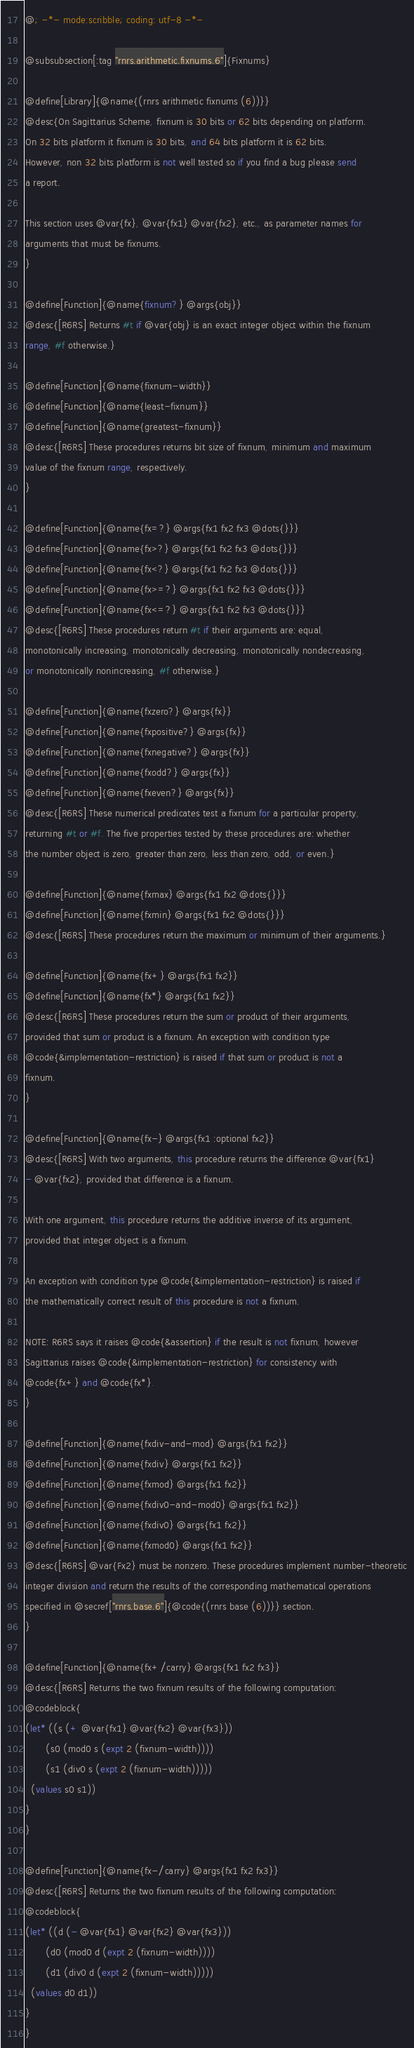Convert code to text. <code><loc_0><loc_0><loc_500><loc_500><_Racket_>@; -*- mode:scribble; coding: utf-8 -*-

@subsubsection[:tag "rnrs.arithmetic.fixnums.6"]{Fixnums}

@define[Library]{@name{(rnrs arithmetic fixnums (6))}}
@desc{On Sagittarius Scheme, fixnum is 30 bits or 62 bits depending on platform.
On 32 bits platform it fixnum is 30 bits, and 64 bits platform it is 62 bits.
However, non 32 bits platform is not well tested so if you find a bug please send
a report.

This section uses @var{fx}, @var{fx1} @var{fx2}, etc., as parameter names for
arguments that must be fixnums.
}

@define[Function]{@name{fixnum?} @args{obj}}
@desc{[R6RS] Returns #t if @var{obj} is an exact integer object within the fixnum
range, #f otherwise.}

@define[Function]{@name{fixnum-width}}
@define[Function]{@name{least-fixnum}}
@define[Function]{@name{greatest-fixnum}}
@desc{[R6RS] These procedures returns bit size of fixnum, minimum and maximum
value of the fixnum range, respectively.
}

@define[Function]{@name{fx=?} @args{fx1 fx2 fx3 @dots{}}}
@define[Function]{@name{fx>?} @args{fx1 fx2 fx3 @dots{}}}
@define[Function]{@name{fx<?} @args{fx1 fx2 fx3 @dots{}}}
@define[Function]{@name{fx>=?} @args{fx1 fx2 fx3 @dots{}}}
@define[Function]{@name{fx<=?} @args{fx1 fx2 fx3 @dots{}}}
@desc{[R6RS] These procedures return #t if their arguments are: equal,
monotonically increasing, monotonically decreasing, monotonically nondecreasing,
or monotonically nonincreasing, #f otherwise.}

@define[Function]{@name{fxzero?} @args{fx}}
@define[Function]{@name{fxpositive?} @args{fx}}
@define[Function]{@name{fxnegative?} @args{fx}}
@define[Function]{@name{fxodd?} @args{fx}}
@define[Function]{@name{fxeven?} @args{fx}}
@desc{[R6RS] These numerical predicates test a fixnum for a particular property,
returning #t or #f. The five properties tested by these procedures are: whether
the number object is zero, greater than zero, less than zero, odd, or even.}

@define[Function]{@name{fxmax} @args{fx1 fx2 @dots{}}}
@define[Function]{@name{fxmin} @args{fx1 fx2 @dots{}}}
@desc{[R6RS] These procedures return the maximum or minimum of their arguments.}

@define[Function]{@name{fx+} @args{fx1 fx2}}
@define[Function]{@name{fx*} @args{fx1 fx2}}
@desc{[R6RS] These procedures return the sum or product of their arguments,
provided that sum or product is a fixnum. An exception with condition type 
@code{&implementation-restriction} is raised if that sum or product is not a
fixnum.
}

@define[Function]{@name{fx-} @args{fx1 :optional fx2}}
@desc{[R6RS] With two arguments, this procedure returns the difference @var{fx1}
- @var{fx2}, provided that difference is a fixnum.

With one argument, this procedure returns the additive inverse of its argument,
provided that integer object is a fixnum.

An exception with condition type @code{&implementation-restriction} is raised if
the mathematically correct result of this procedure is not a fixnum.

NOTE: R6RS says it raises @code{&assertion} if the result is not fixnum, however
Sagittarius raises @code{&implementation-restriction} for consistency with
@code{fx+} and @code{fx*}.
}

@define[Function]{@name{fxdiv-and-mod} @args{fx1 fx2}}
@define[Function]{@name{fxdiv} @args{fx1 fx2}}
@define[Function]{@name{fxmod} @args{fx1 fx2}}
@define[Function]{@name{fxdiv0-and-mod0} @args{fx1 fx2}}
@define[Function]{@name{fxdiv0} @args{fx1 fx2}}
@define[Function]{@name{fxmod0} @args{fx1 fx2}}
@desc{[R6RS] @var{Fx2} must be nonzero. These procedures implement number-theoretic
integer division and return the results of the corresponding mathematical operations
specified in @secref["rnrs.base.6"]{@code{(rnrs base (6))}} section.
}

@define[Function]{@name{fx+/carry} @args{fx1 fx2 fx3}}
@desc{[R6RS] Returns the two fixnum results of the following computation:
@codeblock{
(let* ((s (+ @var{fx1} @var{fx2} @var{fx3}))
       (s0 (mod0 s (expt 2 (fixnum-width))))
       (s1 (div0 s (expt 2 (fixnum-width)))))
  (values s0 s1))
}
}

@define[Function]{@name{fx-/carry} @args{fx1 fx2 fx3}}
@desc{[R6RS] Returns the two fixnum results of the following computation:
@codeblock{
(let* ((d (- @var{fx1} @var{fx2} @var{fx3}))
       (d0 (mod0 d (expt 2 (fixnum-width))))
       (d1 (div0 d (expt 2 (fixnum-width)))))
  (values d0 d1))
}
}
</code> 